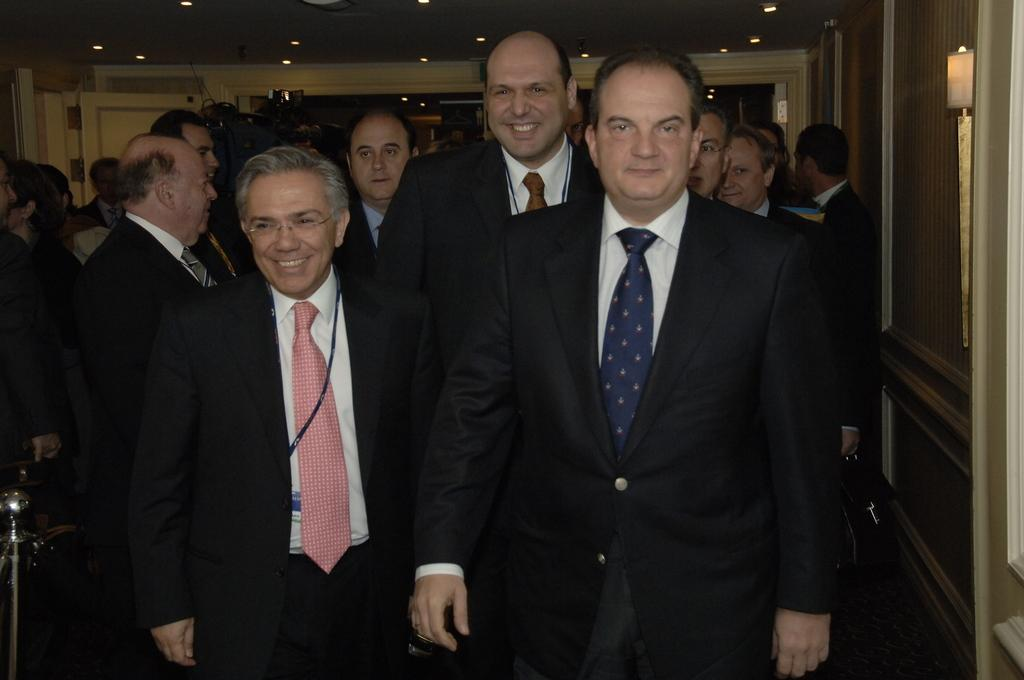What are the people in the image doing? The people in the image are standing. What are the people wearing? The people are wearing suits. What is on the right side of the image? There is a wall on the right side of the image. What is visible above the people in the image? There is a ceiling visible in the image. What can be seen on the ceiling? There are lights on the ceiling. What type of shade is being provided by the scarecrow in the image? There is no scarecrow present in the image, so no shade is being provided by a scarecrow. 